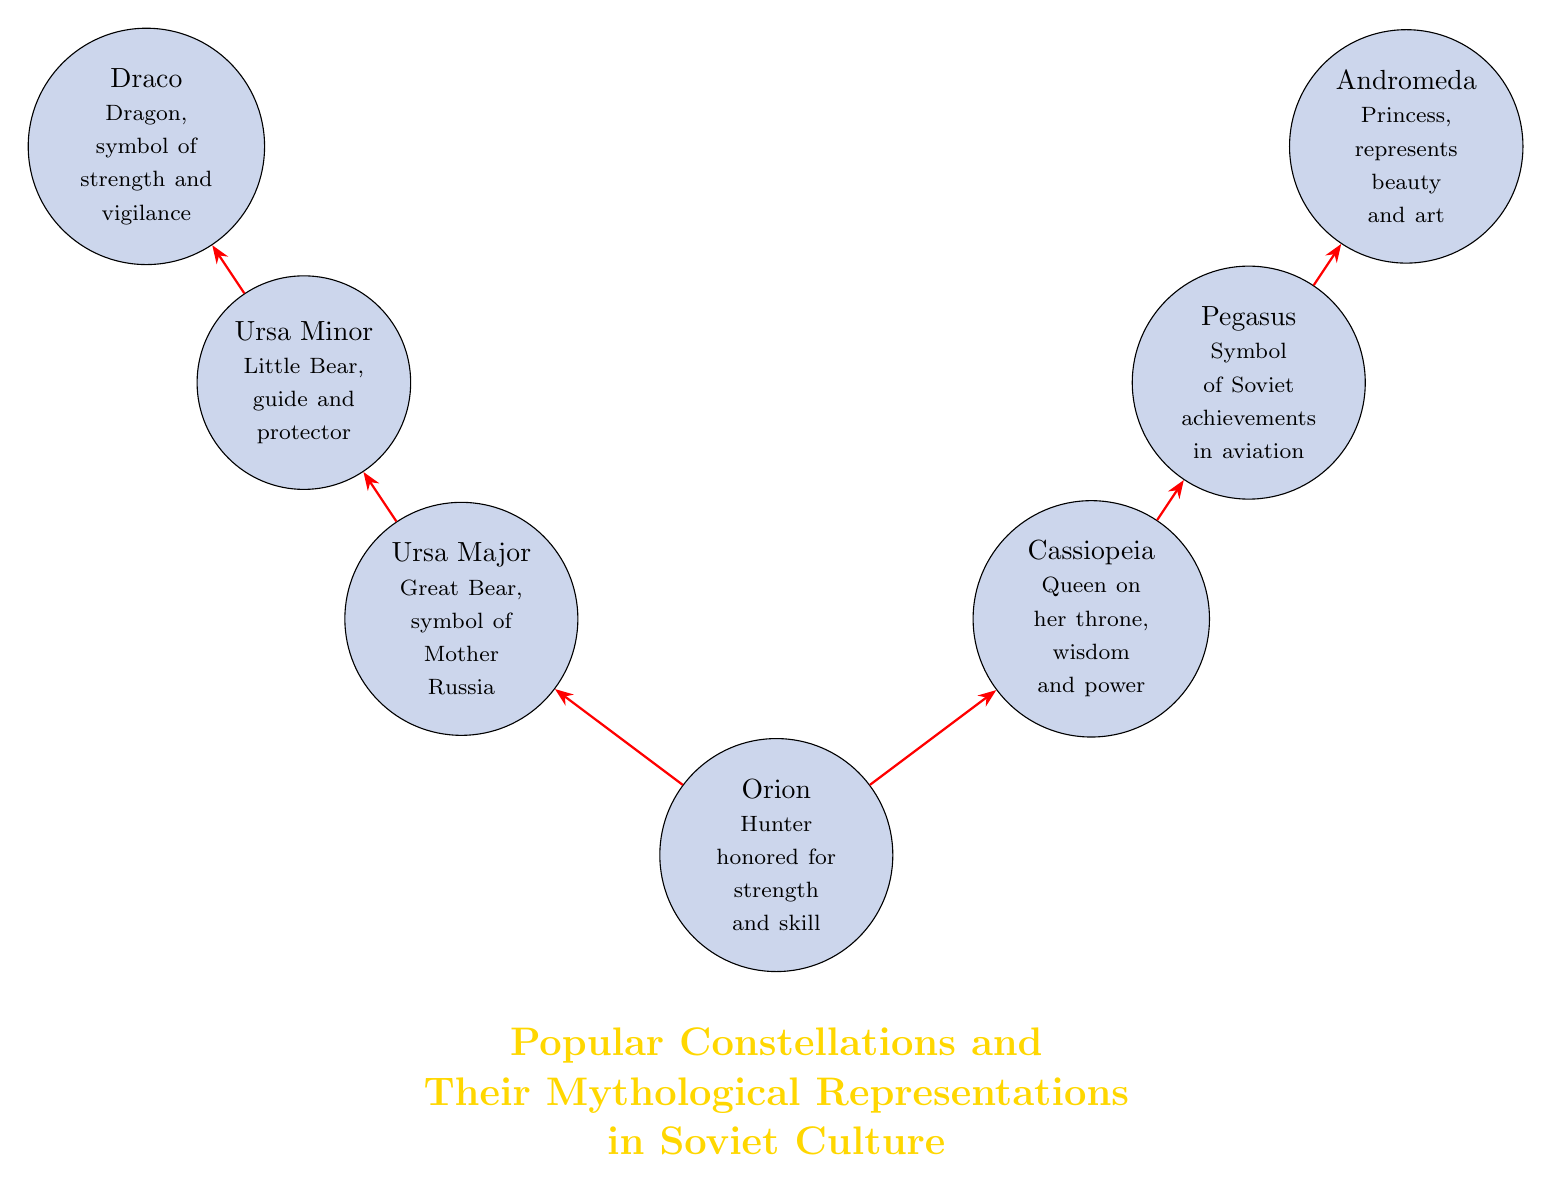What is depicted at the center of the diagram? The central node represents the constellation Orion, which is labeled as the hunter honored for strength and skill.
Answer: Orion How many constellations are shown in the diagram? By counting the nodes in the diagram, we see there are a total of seven constellations depicted.
Answer: 7 What is the representation of Ursa Major in Soviet culture? The diagram states that Ursa Major symbolizes Mother Russia, illustrating its significance beyond just the constellation itself.
Answer: Great Bear, symbol of Mother Russia Which constellation is connected to both Orion and Ursa Major? The diagram shows a direct connection from Orion to Ursa Major, indicating that these two constellations are linked.
Answer: Ursa Major What does the constellation Pegasus symbolize? According to the diagram, Pegasus represents Soviet achievements in aviation, highlighting its importance in cultural narratives.
Answer: Symbol of Soviet achievements in aviation Which two constellations are compared for wisdom and art? The diagram connects Cassiopeia, representing wisdom and power, and Andromeda, representing beauty and art, suggesting a relationship between these attributes.
Answer: Cassiopeia and Andromeda What does Draco symbolize in the context of this diagram? Draco is labeled as the dragon and symbolizes strength and vigilance in the Soviet cultural representation, pointing to its role as a strong guardian figure.
Answer: Dragon, symbol of strength and vigilance How is Ursa Minor connected to Ursa Major? Ursa Minor is directly connected to Ursa Major in the diagram, indicating a familial or protective relationship between the two constellations.
Answer: Guide and protector What is the overall theme of this diagram? The title at the bottom of the diagram clearly states that it focuses on popular constellations and their mythological representations in Soviet culture, encapsulating the essence of the visual.
Answer: Popular Constellations and Their Mythological Representations in Soviet Culture 